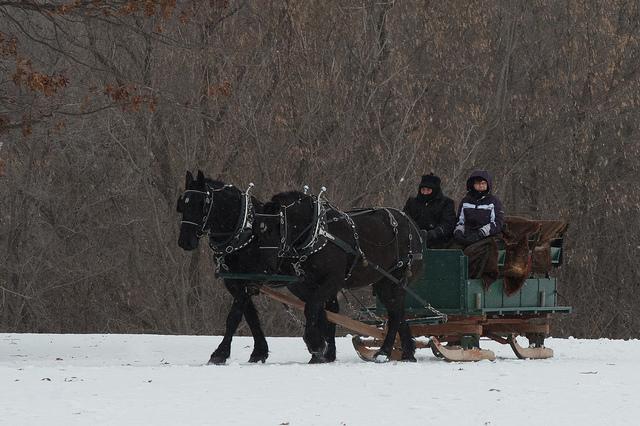What is on the ground?
Write a very short answer. Snow. What are the horses pulling?
Keep it brief. Sleigh. Is this an old picture?
Write a very short answer. No. What color are the horses?
Give a very brief answer. Black. What is the boy wearing?
Give a very brief answer. Coat. Is the horse safe?
Give a very brief answer. Yes. Can you see any detail on the horse?
Answer briefly. No. 